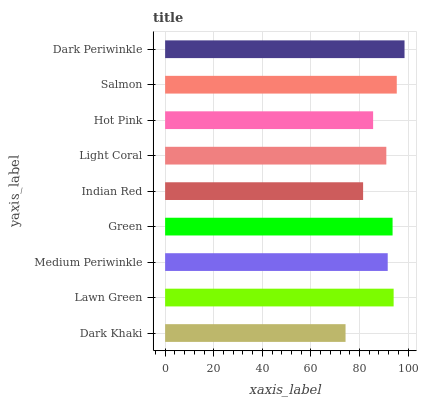Is Dark Khaki the minimum?
Answer yes or no. Yes. Is Dark Periwinkle the maximum?
Answer yes or no. Yes. Is Lawn Green the minimum?
Answer yes or no. No. Is Lawn Green the maximum?
Answer yes or no. No. Is Lawn Green greater than Dark Khaki?
Answer yes or no. Yes. Is Dark Khaki less than Lawn Green?
Answer yes or no. Yes. Is Dark Khaki greater than Lawn Green?
Answer yes or no. No. Is Lawn Green less than Dark Khaki?
Answer yes or no. No. Is Medium Periwinkle the high median?
Answer yes or no. Yes. Is Medium Periwinkle the low median?
Answer yes or no. Yes. Is Light Coral the high median?
Answer yes or no. No. Is Dark Khaki the low median?
Answer yes or no. No. 